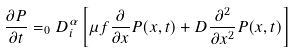<formula> <loc_0><loc_0><loc_500><loc_500>\frac { \partial P } { \partial t } = _ { 0 } D _ { i } ^ { \alpha } \left [ \mu f \frac { \partial } { \partial x } P ( x , t ) + D \frac { \partial ^ { 2 } } { \partial x ^ { 2 } } P ( x , t ) \right ]</formula> 